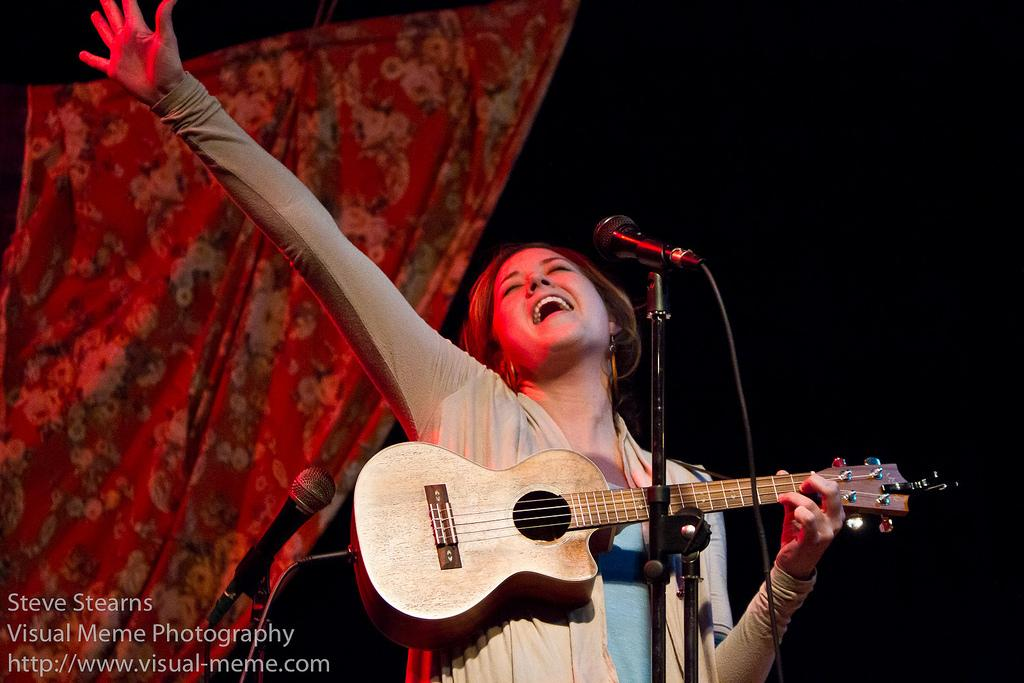Who is the main subject in the image? There is a woman in the image. What is the woman doing in the image? The woman is playing a guitar and singing. What object is in front of the woman? There is a microphone in front of the woman. What type of shoes is the woman wearing in the image? The provided facts do not mention any shoes, so we cannot determine the type of shoes the woman is wearing in the image. 